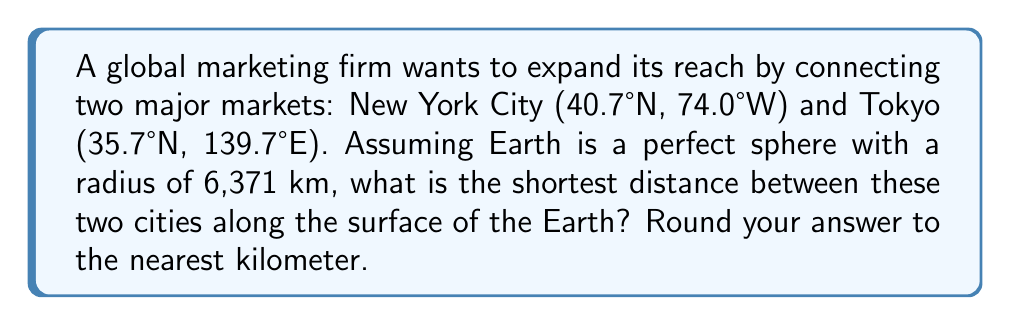Could you help me with this problem? To solve this problem, we'll use the great circle distance formula, which gives the shortest path between two points on a sphere. This is relevant to global market expansion as it helps determine the most efficient route for logistics and communication.

Step 1: Convert the coordinates to radians.
New York: $\phi_1 = 40.7° \times \frac{\pi}{180} = 0.7101$ rad, $\lambda_1 = -74.0° \times \frac{\pi}{180} = -1.2915$ rad
Tokyo: $\phi_2 = 35.7° \times \frac{\pi}{180} = 0.6230$ rad, $\lambda_2 = 139.7° \times \frac{\pi}{180} = 2.4382$ rad

Step 2: Calculate the central angle $\Delta\sigma$ using the great circle distance formula:
$$\Delta\sigma = \arccos(\sin\phi_1 \sin\phi_2 + \cos\phi_1 \cos\phi_2 \cos(\lambda_2 - \lambda_1))$$

$$\Delta\sigma = \arccos(\sin(0.7101) \sin(0.6230) + \cos(0.7101) \cos(0.6230) \cos(2.4382 - (-1.2915)))$$

$$\Delta\sigma = \arccos(0.4133 + 0.5715 \times 0.7826) = \arccos(0.8605) = 0.5305 \text{ rad}$$

Step 3: Calculate the distance $d$ by multiplying the central angle by Earth's radius:
$$d = 0.5305 \times 6371 = 3378.1 \text{ km}$$

Step 4: Round to the nearest kilometer:
$$d \approx 3378 \text{ km}$$
Answer: 3378 km 